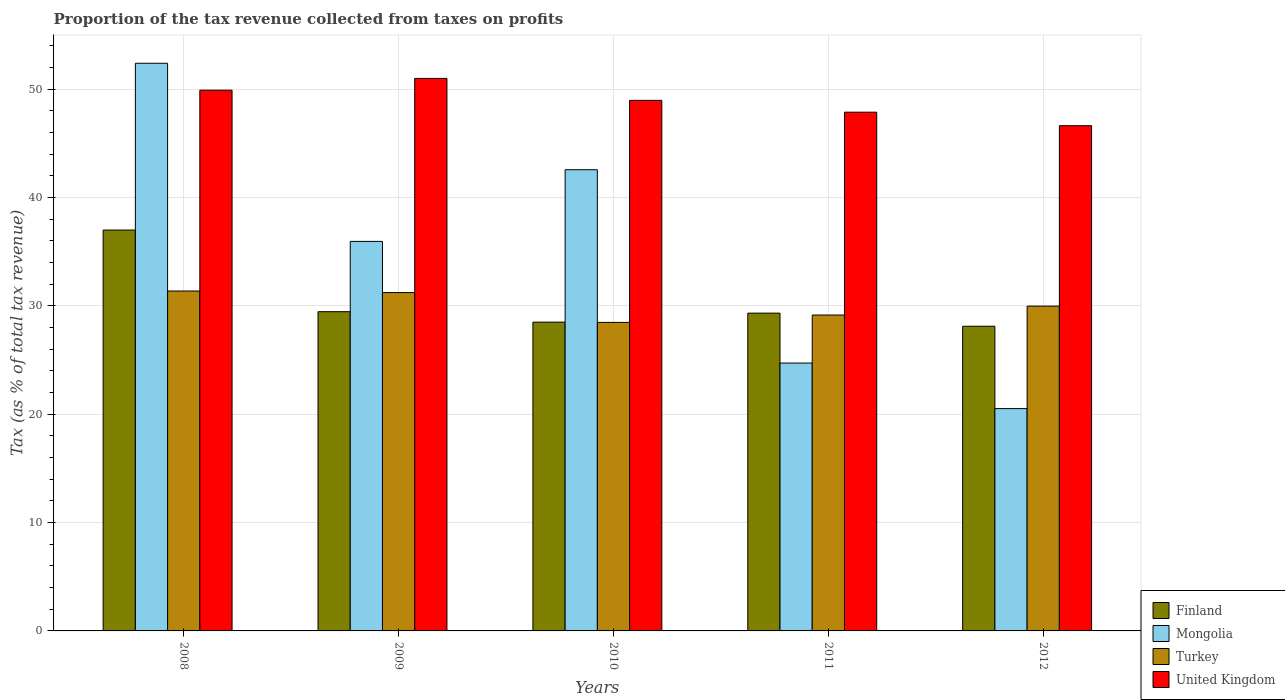How many different coloured bars are there?
Offer a terse response. 4. How many groups of bars are there?
Keep it short and to the point. 5. Are the number of bars per tick equal to the number of legend labels?
Give a very brief answer. Yes. Are the number of bars on each tick of the X-axis equal?
Make the answer very short. Yes. How many bars are there on the 1st tick from the left?
Offer a terse response. 4. What is the label of the 1st group of bars from the left?
Your answer should be very brief. 2008. In how many cases, is the number of bars for a given year not equal to the number of legend labels?
Your response must be concise. 0. What is the proportion of the tax revenue collected in Turkey in 2012?
Make the answer very short. 29.98. Across all years, what is the maximum proportion of the tax revenue collected in Mongolia?
Your answer should be compact. 52.4. Across all years, what is the minimum proportion of the tax revenue collected in Turkey?
Ensure brevity in your answer.  28.48. In which year was the proportion of the tax revenue collected in United Kingdom maximum?
Keep it short and to the point. 2009. What is the total proportion of the tax revenue collected in Finland in the graph?
Your answer should be compact. 152.42. What is the difference between the proportion of the tax revenue collected in United Kingdom in 2008 and that in 2009?
Provide a short and direct response. -1.09. What is the difference between the proportion of the tax revenue collected in Mongolia in 2010 and the proportion of the tax revenue collected in Turkey in 2009?
Your answer should be very brief. 11.34. What is the average proportion of the tax revenue collected in Finland per year?
Keep it short and to the point. 30.48. In the year 2009, what is the difference between the proportion of the tax revenue collected in United Kingdom and proportion of the tax revenue collected in Turkey?
Offer a very short reply. 19.77. In how many years, is the proportion of the tax revenue collected in Mongolia greater than 32 %?
Your answer should be compact. 3. What is the ratio of the proportion of the tax revenue collected in Mongolia in 2010 to that in 2012?
Your answer should be very brief. 2.07. What is the difference between the highest and the second highest proportion of the tax revenue collected in Mongolia?
Keep it short and to the point. 9.83. What is the difference between the highest and the lowest proportion of the tax revenue collected in Turkey?
Your response must be concise. 2.9. In how many years, is the proportion of the tax revenue collected in Turkey greater than the average proportion of the tax revenue collected in Turkey taken over all years?
Provide a short and direct response. 2. Is the sum of the proportion of the tax revenue collected in Turkey in 2010 and 2012 greater than the maximum proportion of the tax revenue collected in Finland across all years?
Your answer should be very brief. Yes. What does the 4th bar from the right in 2011 represents?
Provide a succinct answer. Finland. Is it the case that in every year, the sum of the proportion of the tax revenue collected in Mongolia and proportion of the tax revenue collected in Finland is greater than the proportion of the tax revenue collected in Turkey?
Offer a terse response. Yes. How many years are there in the graph?
Ensure brevity in your answer.  5. What is the difference between two consecutive major ticks on the Y-axis?
Keep it short and to the point. 10. Are the values on the major ticks of Y-axis written in scientific E-notation?
Offer a very short reply. No. Does the graph contain any zero values?
Offer a terse response. No. Where does the legend appear in the graph?
Make the answer very short. Bottom right. What is the title of the graph?
Offer a terse response. Proportion of the tax revenue collected from taxes on profits. Does "Mali" appear as one of the legend labels in the graph?
Your answer should be very brief. No. What is the label or title of the Y-axis?
Give a very brief answer. Tax (as % of total tax revenue). What is the Tax (as % of total tax revenue) of Finland in 2008?
Ensure brevity in your answer.  37. What is the Tax (as % of total tax revenue) in Mongolia in 2008?
Your answer should be compact. 52.4. What is the Tax (as % of total tax revenue) of Turkey in 2008?
Your answer should be compact. 31.37. What is the Tax (as % of total tax revenue) of United Kingdom in 2008?
Give a very brief answer. 49.91. What is the Tax (as % of total tax revenue) of Finland in 2009?
Keep it short and to the point. 29.46. What is the Tax (as % of total tax revenue) in Mongolia in 2009?
Provide a short and direct response. 35.95. What is the Tax (as % of total tax revenue) of Turkey in 2009?
Provide a short and direct response. 31.23. What is the Tax (as % of total tax revenue) of United Kingdom in 2009?
Your answer should be compact. 51. What is the Tax (as % of total tax revenue) of Finland in 2010?
Make the answer very short. 28.5. What is the Tax (as % of total tax revenue) of Mongolia in 2010?
Your response must be concise. 42.57. What is the Tax (as % of total tax revenue) in Turkey in 2010?
Provide a succinct answer. 28.48. What is the Tax (as % of total tax revenue) of United Kingdom in 2010?
Offer a very short reply. 48.97. What is the Tax (as % of total tax revenue) of Finland in 2011?
Offer a very short reply. 29.33. What is the Tax (as % of total tax revenue) of Mongolia in 2011?
Your answer should be very brief. 24.72. What is the Tax (as % of total tax revenue) in Turkey in 2011?
Give a very brief answer. 29.16. What is the Tax (as % of total tax revenue) of United Kingdom in 2011?
Provide a succinct answer. 47.88. What is the Tax (as % of total tax revenue) in Finland in 2012?
Ensure brevity in your answer.  28.12. What is the Tax (as % of total tax revenue) of Mongolia in 2012?
Offer a very short reply. 20.52. What is the Tax (as % of total tax revenue) of Turkey in 2012?
Ensure brevity in your answer.  29.98. What is the Tax (as % of total tax revenue) of United Kingdom in 2012?
Ensure brevity in your answer.  46.63. Across all years, what is the maximum Tax (as % of total tax revenue) in Finland?
Offer a very short reply. 37. Across all years, what is the maximum Tax (as % of total tax revenue) in Mongolia?
Make the answer very short. 52.4. Across all years, what is the maximum Tax (as % of total tax revenue) of Turkey?
Provide a short and direct response. 31.37. Across all years, what is the maximum Tax (as % of total tax revenue) in United Kingdom?
Keep it short and to the point. 51. Across all years, what is the minimum Tax (as % of total tax revenue) of Finland?
Give a very brief answer. 28.12. Across all years, what is the minimum Tax (as % of total tax revenue) of Mongolia?
Provide a succinct answer. 20.52. Across all years, what is the minimum Tax (as % of total tax revenue) of Turkey?
Your answer should be very brief. 28.48. Across all years, what is the minimum Tax (as % of total tax revenue) in United Kingdom?
Provide a short and direct response. 46.63. What is the total Tax (as % of total tax revenue) in Finland in the graph?
Ensure brevity in your answer.  152.42. What is the total Tax (as % of total tax revenue) of Mongolia in the graph?
Provide a short and direct response. 176.16. What is the total Tax (as % of total tax revenue) of Turkey in the graph?
Give a very brief answer. 150.22. What is the total Tax (as % of total tax revenue) of United Kingdom in the graph?
Keep it short and to the point. 244.39. What is the difference between the Tax (as % of total tax revenue) in Finland in 2008 and that in 2009?
Your answer should be very brief. 7.54. What is the difference between the Tax (as % of total tax revenue) of Mongolia in 2008 and that in 2009?
Provide a short and direct response. 16.44. What is the difference between the Tax (as % of total tax revenue) in Turkey in 2008 and that in 2009?
Give a very brief answer. 0.14. What is the difference between the Tax (as % of total tax revenue) in United Kingdom in 2008 and that in 2009?
Provide a succinct answer. -1.09. What is the difference between the Tax (as % of total tax revenue) in Finland in 2008 and that in 2010?
Your answer should be compact. 8.5. What is the difference between the Tax (as % of total tax revenue) in Mongolia in 2008 and that in 2010?
Ensure brevity in your answer.  9.83. What is the difference between the Tax (as % of total tax revenue) of Turkey in 2008 and that in 2010?
Provide a short and direct response. 2.9. What is the difference between the Tax (as % of total tax revenue) of United Kingdom in 2008 and that in 2010?
Provide a short and direct response. 0.94. What is the difference between the Tax (as % of total tax revenue) of Finland in 2008 and that in 2011?
Ensure brevity in your answer.  7.67. What is the difference between the Tax (as % of total tax revenue) in Mongolia in 2008 and that in 2011?
Keep it short and to the point. 27.67. What is the difference between the Tax (as % of total tax revenue) of Turkey in 2008 and that in 2011?
Keep it short and to the point. 2.22. What is the difference between the Tax (as % of total tax revenue) in United Kingdom in 2008 and that in 2011?
Ensure brevity in your answer.  2.03. What is the difference between the Tax (as % of total tax revenue) of Finland in 2008 and that in 2012?
Offer a terse response. 8.88. What is the difference between the Tax (as % of total tax revenue) in Mongolia in 2008 and that in 2012?
Keep it short and to the point. 31.87. What is the difference between the Tax (as % of total tax revenue) of Turkey in 2008 and that in 2012?
Provide a succinct answer. 1.39. What is the difference between the Tax (as % of total tax revenue) of United Kingdom in 2008 and that in 2012?
Provide a short and direct response. 3.28. What is the difference between the Tax (as % of total tax revenue) in Finland in 2009 and that in 2010?
Give a very brief answer. 0.96. What is the difference between the Tax (as % of total tax revenue) in Mongolia in 2009 and that in 2010?
Ensure brevity in your answer.  -6.62. What is the difference between the Tax (as % of total tax revenue) of Turkey in 2009 and that in 2010?
Offer a terse response. 2.75. What is the difference between the Tax (as % of total tax revenue) in United Kingdom in 2009 and that in 2010?
Give a very brief answer. 2.03. What is the difference between the Tax (as % of total tax revenue) in Finland in 2009 and that in 2011?
Provide a succinct answer. 0.13. What is the difference between the Tax (as % of total tax revenue) of Mongolia in 2009 and that in 2011?
Your answer should be compact. 11.23. What is the difference between the Tax (as % of total tax revenue) in Turkey in 2009 and that in 2011?
Offer a very short reply. 2.07. What is the difference between the Tax (as % of total tax revenue) of United Kingdom in 2009 and that in 2011?
Your response must be concise. 3.12. What is the difference between the Tax (as % of total tax revenue) in Finland in 2009 and that in 2012?
Your answer should be very brief. 1.34. What is the difference between the Tax (as % of total tax revenue) of Mongolia in 2009 and that in 2012?
Make the answer very short. 15.43. What is the difference between the Tax (as % of total tax revenue) of Turkey in 2009 and that in 2012?
Offer a very short reply. 1.25. What is the difference between the Tax (as % of total tax revenue) of United Kingdom in 2009 and that in 2012?
Make the answer very short. 4.37. What is the difference between the Tax (as % of total tax revenue) in Finland in 2010 and that in 2011?
Offer a very short reply. -0.83. What is the difference between the Tax (as % of total tax revenue) of Mongolia in 2010 and that in 2011?
Your response must be concise. 17.84. What is the difference between the Tax (as % of total tax revenue) of Turkey in 2010 and that in 2011?
Your response must be concise. -0.68. What is the difference between the Tax (as % of total tax revenue) in United Kingdom in 2010 and that in 2011?
Make the answer very short. 1.09. What is the difference between the Tax (as % of total tax revenue) in Finland in 2010 and that in 2012?
Make the answer very short. 0.38. What is the difference between the Tax (as % of total tax revenue) of Mongolia in 2010 and that in 2012?
Give a very brief answer. 22.05. What is the difference between the Tax (as % of total tax revenue) in Turkey in 2010 and that in 2012?
Provide a succinct answer. -1.5. What is the difference between the Tax (as % of total tax revenue) in United Kingdom in 2010 and that in 2012?
Your answer should be compact. 2.34. What is the difference between the Tax (as % of total tax revenue) in Finland in 2011 and that in 2012?
Keep it short and to the point. 1.21. What is the difference between the Tax (as % of total tax revenue) in Mongolia in 2011 and that in 2012?
Your answer should be compact. 4.2. What is the difference between the Tax (as % of total tax revenue) of Turkey in 2011 and that in 2012?
Ensure brevity in your answer.  -0.82. What is the difference between the Tax (as % of total tax revenue) in United Kingdom in 2011 and that in 2012?
Make the answer very short. 1.25. What is the difference between the Tax (as % of total tax revenue) in Finland in 2008 and the Tax (as % of total tax revenue) in Mongolia in 2009?
Provide a short and direct response. 1.05. What is the difference between the Tax (as % of total tax revenue) in Finland in 2008 and the Tax (as % of total tax revenue) in Turkey in 2009?
Provide a succinct answer. 5.77. What is the difference between the Tax (as % of total tax revenue) of Finland in 2008 and the Tax (as % of total tax revenue) of United Kingdom in 2009?
Ensure brevity in your answer.  -14. What is the difference between the Tax (as % of total tax revenue) of Mongolia in 2008 and the Tax (as % of total tax revenue) of Turkey in 2009?
Your response must be concise. 21.17. What is the difference between the Tax (as % of total tax revenue) of Mongolia in 2008 and the Tax (as % of total tax revenue) of United Kingdom in 2009?
Your answer should be compact. 1.4. What is the difference between the Tax (as % of total tax revenue) in Turkey in 2008 and the Tax (as % of total tax revenue) in United Kingdom in 2009?
Offer a very short reply. -19.62. What is the difference between the Tax (as % of total tax revenue) in Finland in 2008 and the Tax (as % of total tax revenue) in Mongolia in 2010?
Provide a succinct answer. -5.57. What is the difference between the Tax (as % of total tax revenue) in Finland in 2008 and the Tax (as % of total tax revenue) in Turkey in 2010?
Offer a very short reply. 8.52. What is the difference between the Tax (as % of total tax revenue) in Finland in 2008 and the Tax (as % of total tax revenue) in United Kingdom in 2010?
Your response must be concise. -11.97. What is the difference between the Tax (as % of total tax revenue) in Mongolia in 2008 and the Tax (as % of total tax revenue) in Turkey in 2010?
Offer a terse response. 23.92. What is the difference between the Tax (as % of total tax revenue) of Mongolia in 2008 and the Tax (as % of total tax revenue) of United Kingdom in 2010?
Offer a terse response. 3.43. What is the difference between the Tax (as % of total tax revenue) in Turkey in 2008 and the Tax (as % of total tax revenue) in United Kingdom in 2010?
Provide a short and direct response. -17.6. What is the difference between the Tax (as % of total tax revenue) in Finland in 2008 and the Tax (as % of total tax revenue) in Mongolia in 2011?
Your answer should be very brief. 12.28. What is the difference between the Tax (as % of total tax revenue) in Finland in 2008 and the Tax (as % of total tax revenue) in Turkey in 2011?
Make the answer very short. 7.84. What is the difference between the Tax (as % of total tax revenue) in Finland in 2008 and the Tax (as % of total tax revenue) in United Kingdom in 2011?
Give a very brief answer. -10.88. What is the difference between the Tax (as % of total tax revenue) of Mongolia in 2008 and the Tax (as % of total tax revenue) of Turkey in 2011?
Your answer should be very brief. 23.24. What is the difference between the Tax (as % of total tax revenue) of Mongolia in 2008 and the Tax (as % of total tax revenue) of United Kingdom in 2011?
Your response must be concise. 4.51. What is the difference between the Tax (as % of total tax revenue) of Turkey in 2008 and the Tax (as % of total tax revenue) of United Kingdom in 2011?
Provide a succinct answer. -16.51. What is the difference between the Tax (as % of total tax revenue) of Finland in 2008 and the Tax (as % of total tax revenue) of Mongolia in 2012?
Ensure brevity in your answer.  16.48. What is the difference between the Tax (as % of total tax revenue) in Finland in 2008 and the Tax (as % of total tax revenue) in Turkey in 2012?
Offer a terse response. 7.02. What is the difference between the Tax (as % of total tax revenue) of Finland in 2008 and the Tax (as % of total tax revenue) of United Kingdom in 2012?
Offer a very short reply. -9.63. What is the difference between the Tax (as % of total tax revenue) in Mongolia in 2008 and the Tax (as % of total tax revenue) in Turkey in 2012?
Give a very brief answer. 22.42. What is the difference between the Tax (as % of total tax revenue) of Mongolia in 2008 and the Tax (as % of total tax revenue) of United Kingdom in 2012?
Provide a succinct answer. 5.76. What is the difference between the Tax (as % of total tax revenue) of Turkey in 2008 and the Tax (as % of total tax revenue) of United Kingdom in 2012?
Offer a terse response. -15.26. What is the difference between the Tax (as % of total tax revenue) in Finland in 2009 and the Tax (as % of total tax revenue) in Mongolia in 2010?
Your answer should be very brief. -13.1. What is the difference between the Tax (as % of total tax revenue) of Finland in 2009 and the Tax (as % of total tax revenue) of Turkey in 2010?
Your answer should be very brief. 0.99. What is the difference between the Tax (as % of total tax revenue) in Finland in 2009 and the Tax (as % of total tax revenue) in United Kingdom in 2010?
Your answer should be very brief. -19.51. What is the difference between the Tax (as % of total tax revenue) in Mongolia in 2009 and the Tax (as % of total tax revenue) in Turkey in 2010?
Ensure brevity in your answer.  7.48. What is the difference between the Tax (as % of total tax revenue) in Mongolia in 2009 and the Tax (as % of total tax revenue) in United Kingdom in 2010?
Your answer should be very brief. -13.02. What is the difference between the Tax (as % of total tax revenue) in Turkey in 2009 and the Tax (as % of total tax revenue) in United Kingdom in 2010?
Your answer should be compact. -17.74. What is the difference between the Tax (as % of total tax revenue) in Finland in 2009 and the Tax (as % of total tax revenue) in Mongolia in 2011?
Keep it short and to the point. 4.74. What is the difference between the Tax (as % of total tax revenue) in Finland in 2009 and the Tax (as % of total tax revenue) in Turkey in 2011?
Make the answer very short. 0.31. What is the difference between the Tax (as % of total tax revenue) in Finland in 2009 and the Tax (as % of total tax revenue) in United Kingdom in 2011?
Your response must be concise. -18.42. What is the difference between the Tax (as % of total tax revenue) of Mongolia in 2009 and the Tax (as % of total tax revenue) of Turkey in 2011?
Ensure brevity in your answer.  6.8. What is the difference between the Tax (as % of total tax revenue) in Mongolia in 2009 and the Tax (as % of total tax revenue) in United Kingdom in 2011?
Keep it short and to the point. -11.93. What is the difference between the Tax (as % of total tax revenue) in Turkey in 2009 and the Tax (as % of total tax revenue) in United Kingdom in 2011?
Make the answer very short. -16.65. What is the difference between the Tax (as % of total tax revenue) of Finland in 2009 and the Tax (as % of total tax revenue) of Mongolia in 2012?
Provide a short and direct response. 8.94. What is the difference between the Tax (as % of total tax revenue) in Finland in 2009 and the Tax (as % of total tax revenue) in Turkey in 2012?
Your response must be concise. -0.52. What is the difference between the Tax (as % of total tax revenue) of Finland in 2009 and the Tax (as % of total tax revenue) of United Kingdom in 2012?
Provide a succinct answer. -17.17. What is the difference between the Tax (as % of total tax revenue) of Mongolia in 2009 and the Tax (as % of total tax revenue) of Turkey in 2012?
Make the answer very short. 5.97. What is the difference between the Tax (as % of total tax revenue) in Mongolia in 2009 and the Tax (as % of total tax revenue) in United Kingdom in 2012?
Give a very brief answer. -10.68. What is the difference between the Tax (as % of total tax revenue) in Turkey in 2009 and the Tax (as % of total tax revenue) in United Kingdom in 2012?
Your answer should be compact. -15.4. What is the difference between the Tax (as % of total tax revenue) of Finland in 2010 and the Tax (as % of total tax revenue) of Mongolia in 2011?
Your answer should be compact. 3.78. What is the difference between the Tax (as % of total tax revenue) of Finland in 2010 and the Tax (as % of total tax revenue) of Turkey in 2011?
Ensure brevity in your answer.  -0.66. What is the difference between the Tax (as % of total tax revenue) in Finland in 2010 and the Tax (as % of total tax revenue) in United Kingdom in 2011?
Your response must be concise. -19.38. What is the difference between the Tax (as % of total tax revenue) in Mongolia in 2010 and the Tax (as % of total tax revenue) in Turkey in 2011?
Ensure brevity in your answer.  13.41. What is the difference between the Tax (as % of total tax revenue) of Mongolia in 2010 and the Tax (as % of total tax revenue) of United Kingdom in 2011?
Offer a terse response. -5.31. What is the difference between the Tax (as % of total tax revenue) of Turkey in 2010 and the Tax (as % of total tax revenue) of United Kingdom in 2011?
Make the answer very short. -19.4. What is the difference between the Tax (as % of total tax revenue) of Finland in 2010 and the Tax (as % of total tax revenue) of Mongolia in 2012?
Your response must be concise. 7.98. What is the difference between the Tax (as % of total tax revenue) of Finland in 2010 and the Tax (as % of total tax revenue) of Turkey in 2012?
Your answer should be compact. -1.48. What is the difference between the Tax (as % of total tax revenue) of Finland in 2010 and the Tax (as % of total tax revenue) of United Kingdom in 2012?
Provide a succinct answer. -18.13. What is the difference between the Tax (as % of total tax revenue) in Mongolia in 2010 and the Tax (as % of total tax revenue) in Turkey in 2012?
Provide a succinct answer. 12.59. What is the difference between the Tax (as % of total tax revenue) of Mongolia in 2010 and the Tax (as % of total tax revenue) of United Kingdom in 2012?
Give a very brief answer. -4.06. What is the difference between the Tax (as % of total tax revenue) in Turkey in 2010 and the Tax (as % of total tax revenue) in United Kingdom in 2012?
Your response must be concise. -18.16. What is the difference between the Tax (as % of total tax revenue) of Finland in 2011 and the Tax (as % of total tax revenue) of Mongolia in 2012?
Provide a succinct answer. 8.81. What is the difference between the Tax (as % of total tax revenue) of Finland in 2011 and the Tax (as % of total tax revenue) of Turkey in 2012?
Your answer should be very brief. -0.65. What is the difference between the Tax (as % of total tax revenue) in Finland in 2011 and the Tax (as % of total tax revenue) in United Kingdom in 2012?
Your answer should be compact. -17.3. What is the difference between the Tax (as % of total tax revenue) in Mongolia in 2011 and the Tax (as % of total tax revenue) in Turkey in 2012?
Offer a very short reply. -5.26. What is the difference between the Tax (as % of total tax revenue) of Mongolia in 2011 and the Tax (as % of total tax revenue) of United Kingdom in 2012?
Your answer should be compact. -21.91. What is the difference between the Tax (as % of total tax revenue) of Turkey in 2011 and the Tax (as % of total tax revenue) of United Kingdom in 2012?
Ensure brevity in your answer.  -17.48. What is the average Tax (as % of total tax revenue) of Finland per year?
Offer a terse response. 30.48. What is the average Tax (as % of total tax revenue) in Mongolia per year?
Offer a terse response. 35.23. What is the average Tax (as % of total tax revenue) in Turkey per year?
Offer a terse response. 30.04. What is the average Tax (as % of total tax revenue) in United Kingdom per year?
Provide a succinct answer. 48.88. In the year 2008, what is the difference between the Tax (as % of total tax revenue) in Finland and Tax (as % of total tax revenue) in Mongolia?
Ensure brevity in your answer.  -15.39. In the year 2008, what is the difference between the Tax (as % of total tax revenue) in Finland and Tax (as % of total tax revenue) in Turkey?
Ensure brevity in your answer.  5.63. In the year 2008, what is the difference between the Tax (as % of total tax revenue) in Finland and Tax (as % of total tax revenue) in United Kingdom?
Ensure brevity in your answer.  -12.91. In the year 2008, what is the difference between the Tax (as % of total tax revenue) in Mongolia and Tax (as % of total tax revenue) in Turkey?
Give a very brief answer. 21.02. In the year 2008, what is the difference between the Tax (as % of total tax revenue) in Mongolia and Tax (as % of total tax revenue) in United Kingdom?
Make the answer very short. 2.49. In the year 2008, what is the difference between the Tax (as % of total tax revenue) in Turkey and Tax (as % of total tax revenue) in United Kingdom?
Your answer should be very brief. -18.53. In the year 2009, what is the difference between the Tax (as % of total tax revenue) of Finland and Tax (as % of total tax revenue) of Mongolia?
Make the answer very short. -6.49. In the year 2009, what is the difference between the Tax (as % of total tax revenue) in Finland and Tax (as % of total tax revenue) in Turkey?
Your answer should be very brief. -1.77. In the year 2009, what is the difference between the Tax (as % of total tax revenue) of Finland and Tax (as % of total tax revenue) of United Kingdom?
Ensure brevity in your answer.  -21.53. In the year 2009, what is the difference between the Tax (as % of total tax revenue) of Mongolia and Tax (as % of total tax revenue) of Turkey?
Make the answer very short. 4.72. In the year 2009, what is the difference between the Tax (as % of total tax revenue) of Mongolia and Tax (as % of total tax revenue) of United Kingdom?
Keep it short and to the point. -15.04. In the year 2009, what is the difference between the Tax (as % of total tax revenue) in Turkey and Tax (as % of total tax revenue) in United Kingdom?
Keep it short and to the point. -19.77. In the year 2010, what is the difference between the Tax (as % of total tax revenue) in Finland and Tax (as % of total tax revenue) in Mongolia?
Provide a succinct answer. -14.07. In the year 2010, what is the difference between the Tax (as % of total tax revenue) in Finland and Tax (as % of total tax revenue) in Turkey?
Your answer should be very brief. 0.02. In the year 2010, what is the difference between the Tax (as % of total tax revenue) in Finland and Tax (as % of total tax revenue) in United Kingdom?
Your response must be concise. -20.47. In the year 2010, what is the difference between the Tax (as % of total tax revenue) of Mongolia and Tax (as % of total tax revenue) of Turkey?
Give a very brief answer. 14.09. In the year 2010, what is the difference between the Tax (as % of total tax revenue) in Mongolia and Tax (as % of total tax revenue) in United Kingdom?
Your answer should be compact. -6.4. In the year 2010, what is the difference between the Tax (as % of total tax revenue) in Turkey and Tax (as % of total tax revenue) in United Kingdom?
Provide a succinct answer. -20.49. In the year 2011, what is the difference between the Tax (as % of total tax revenue) of Finland and Tax (as % of total tax revenue) of Mongolia?
Offer a very short reply. 4.61. In the year 2011, what is the difference between the Tax (as % of total tax revenue) in Finland and Tax (as % of total tax revenue) in Turkey?
Provide a short and direct response. 0.17. In the year 2011, what is the difference between the Tax (as % of total tax revenue) in Finland and Tax (as % of total tax revenue) in United Kingdom?
Your response must be concise. -18.55. In the year 2011, what is the difference between the Tax (as % of total tax revenue) in Mongolia and Tax (as % of total tax revenue) in Turkey?
Provide a succinct answer. -4.43. In the year 2011, what is the difference between the Tax (as % of total tax revenue) of Mongolia and Tax (as % of total tax revenue) of United Kingdom?
Offer a terse response. -23.16. In the year 2011, what is the difference between the Tax (as % of total tax revenue) of Turkey and Tax (as % of total tax revenue) of United Kingdom?
Provide a short and direct response. -18.72. In the year 2012, what is the difference between the Tax (as % of total tax revenue) in Finland and Tax (as % of total tax revenue) in Mongolia?
Keep it short and to the point. 7.6. In the year 2012, what is the difference between the Tax (as % of total tax revenue) in Finland and Tax (as % of total tax revenue) in Turkey?
Provide a succinct answer. -1.86. In the year 2012, what is the difference between the Tax (as % of total tax revenue) in Finland and Tax (as % of total tax revenue) in United Kingdom?
Keep it short and to the point. -18.51. In the year 2012, what is the difference between the Tax (as % of total tax revenue) of Mongolia and Tax (as % of total tax revenue) of Turkey?
Your answer should be compact. -9.46. In the year 2012, what is the difference between the Tax (as % of total tax revenue) of Mongolia and Tax (as % of total tax revenue) of United Kingdom?
Provide a short and direct response. -26.11. In the year 2012, what is the difference between the Tax (as % of total tax revenue) of Turkey and Tax (as % of total tax revenue) of United Kingdom?
Your answer should be very brief. -16.65. What is the ratio of the Tax (as % of total tax revenue) in Finland in 2008 to that in 2009?
Your answer should be compact. 1.26. What is the ratio of the Tax (as % of total tax revenue) of Mongolia in 2008 to that in 2009?
Offer a very short reply. 1.46. What is the ratio of the Tax (as % of total tax revenue) of United Kingdom in 2008 to that in 2009?
Your answer should be compact. 0.98. What is the ratio of the Tax (as % of total tax revenue) of Finland in 2008 to that in 2010?
Offer a very short reply. 1.3. What is the ratio of the Tax (as % of total tax revenue) of Mongolia in 2008 to that in 2010?
Provide a short and direct response. 1.23. What is the ratio of the Tax (as % of total tax revenue) in Turkey in 2008 to that in 2010?
Provide a short and direct response. 1.1. What is the ratio of the Tax (as % of total tax revenue) in United Kingdom in 2008 to that in 2010?
Keep it short and to the point. 1.02. What is the ratio of the Tax (as % of total tax revenue) in Finland in 2008 to that in 2011?
Make the answer very short. 1.26. What is the ratio of the Tax (as % of total tax revenue) in Mongolia in 2008 to that in 2011?
Your answer should be compact. 2.12. What is the ratio of the Tax (as % of total tax revenue) of Turkey in 2008 to that in 2011?
Keep it short and to the point. 1.08. What is the ratio of the Tax (as % of total tax revenue) in United Kingdom in 2008 to that in 2011?
Your answer should be compact. 1.04. What is the ratio of the Tax (as % of total tax revenue) in Finland in 2008 to that in 2012?
Offer a terse response. 1.32. What is the ratio of the Tax (as % of total tax revenue) of Mongolia in 2008 to that in 2012?
Provide a short and direct response. 2.55. What is the ratio of the Tax (as % of total tax revenue) of Turkey in 2008 to that in 2012?
Your answer should be very brief. 1.05. What is the ratio of the Tax (as % of total tax revenue) in United Kingdom in 2008 to that in 2012?
Your answer should be very brief. 1.07. What is the ratio of the Tax (as % of total tax revenue) in Finland in 2009 to that in 2010?
Your answer should be very brief. 1.03. What is the ratio of the Tax (as % of total tax revenue) in Mongolia in 2009 to that in 2010?
Give a very brief answer. 0.84. What is the ratio of the Tax (as % of total tax revenue) in Turkey in 2009 to that in 2010?
Make the answer very short. 1.1. What is the ratio of the Tax (as % of total tax revenue) of United Kingdom in 2009 to that in 2010?
Your answer should be very brief. 1.04. What is the ratio of the Tax (as % of total tax revenue) in Mongolia in 2009 to that in 2011?
Ensure brevity in your answer.  1.45. What is the ratio of the Tax (as % of total tax revenue) in Turkey in 2009 to that in 2011?
Make the answer very short. 1.07. What is the ratio of the Tax (as % of total tax revenue) of United Kingdom in 2009 to that in 2011?
Offer a terse response. 1.07. What is the ratio of the Tax (as % of total tax revenue) of Finland in 2009 to that in 2012?
Ensure brevity in your answer.  1.05. What is the ratio of the Tax (as % of total tax revenue) of Mongolia in 2009 to that in 2012?
Ensure brevity in your answer.  1.75. What is the ratio of the Tax (as % of total tax revenue) in Turkey in 2009 to that in 2012?
Offer a very short reply. 1.04. What is the ratio of the Tax (as % of total tax revenue) of United Kingdom in 2009 to that in 2012?
Provide a short and direct response. 1.09. What is the ratio of the Tax (as % of total tax revenue) of Finland in 2010 to that in 2011?
Offer a terse response. 0.97. What is the ratio of the Tax (as % of total tax revenue) of Mongolia in 2010 to that in 2011?
Make the answer very short. 1.72. What is the ratio of the Tax (as % of total tax revenue) of Turkey in 2010 to that in 2011?
Offer a terse response. 0.98. What is the ratio of the Tax (as % of total tax revenue) in United Kingdom in 2010 to that in 2011?
Your response must be concise. 1.02. What is the ratio of the Tax (as % of total tax revenue) in Finland in 2010 to that in 2012?
Your answer should be very brief. 1.01. What is the ratio of the Tax (as % of total tax revenue) in Mongolia in 2010 to that in 2012?
Offer a terse response. 2.07. What is the ratio of the Tax (as % of total tax revenue) of Turkey in 2010 to that in 2012?
Make the answer very short. 0.95. What is the ratio of the Tax (as % of total tax revenue) in United Kingdom in 2010 to that in 2012?
Provide a short and direct response. 1.05. What is the ratio of the Tax (as % of total tax revenue) of Finland in 2011 to that in 2012?
Give a very brief answer. 1.04. What is the ratio of the Tax (as % of total tax revenue) of Mongolia in 2011 to that in 2012?
Provide a short and direct response. 1.2. What is the ratio of the Tax (as % of total tax revenue) in Turkey in 2011 to that in 2012?
Offer a terse response. 0.97. What is the ratio of the Tax (as % of total tax revenue) of United Kingdom in 2011 to that in 2012?
Offer a very short reply. 1.03. What is the difference between the highest and the second highest Tax (as % of total tax revenue) of Finland?
Keep it short and to the point. 7.54. What is the difference between the highest and the second highest Tax (as % of total tax revenue) in Mongolia?
Make the answer very short. 9.83. What is the difference between the highest and the second highest Tax (as % of total tax revenue) of Turkey?
Give a very brief answer. 0.14. What is the difference between the highest and the second highest Tax (as % of total tax revenue) of United Kingdom?
Offer a terse response. 1.09. What is the difference between the highest and the lowest Tax (as % of total tax revenue) of Finland?
Your answer should be compact. 8.88. What is the difference between the highest and the lowest Tax (as % of total tax revenue) of Mongolia?
Ensure brevity in your answer.  31.87. What is the difference between the highest and the lowest Tax (as % of total tax revenue) of Turkey?
Keep it short and to the point. 2.9. What is the difference between the highest and the lowest Tax (as % of total tax revenue) in United Kingdom?
Make the answer very short. 4.37. 